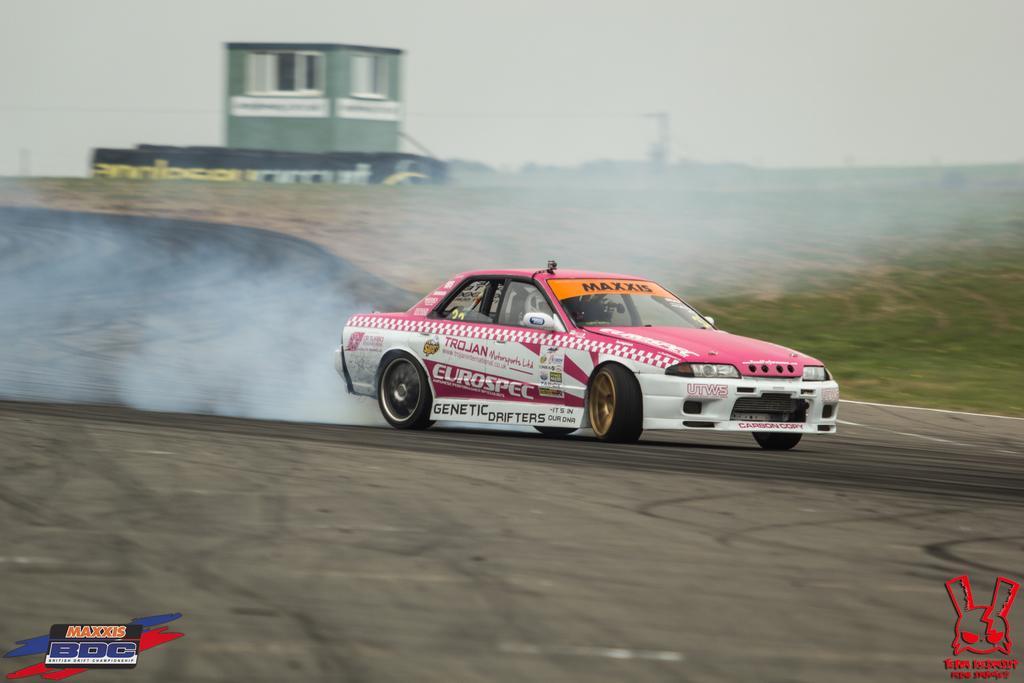Can you describe this image briefly? This is the car moving on the road. I can see a person sitting inside the car. In the background, that looks like a building with the window. These are the watermarks on the image. 